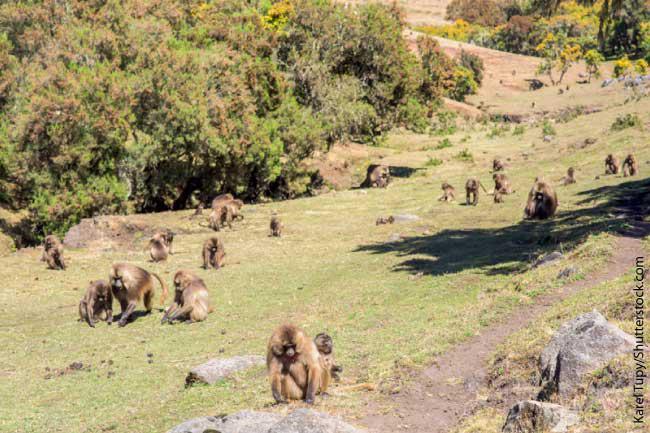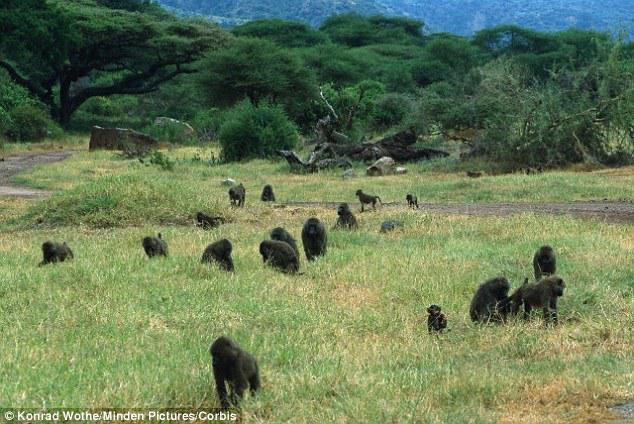The first image is the image on the left, the second image is the image on the right. Evaluate the accuracy of this statement regarding the images: "The right image shows a large group of animals on a road.". Is it true? Answer yes or no. No. The first image is the image on the left, the second image is the image on the right. Considering the images on both sides, is "One image has no more than 7 baboons." valid? Answer yes or no. No. 